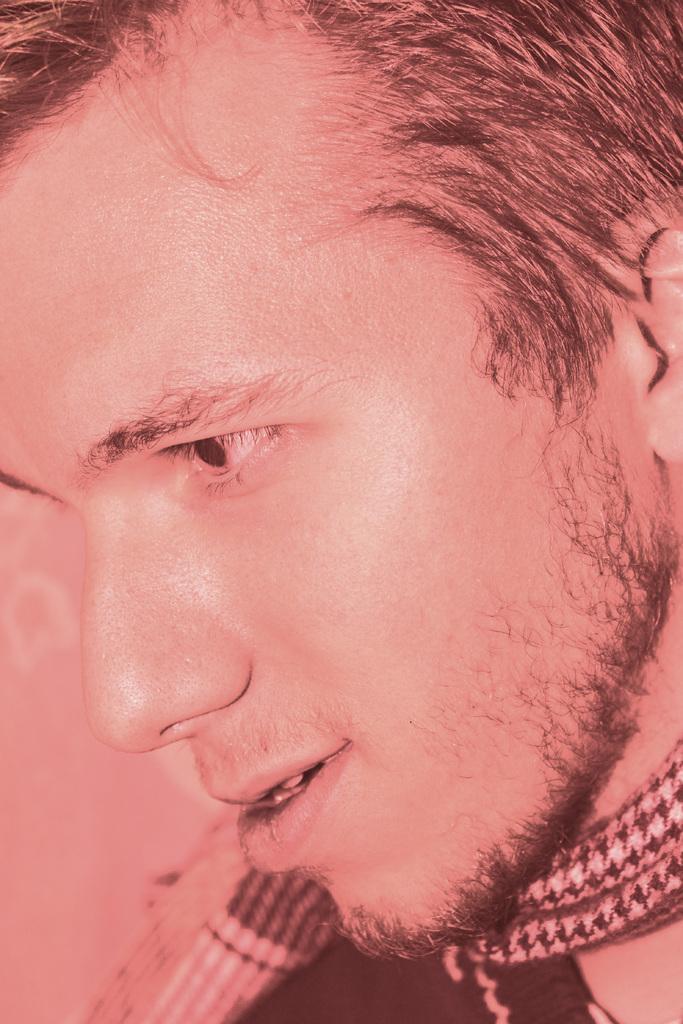Describe this image in one or two sentences. In this image I can see a man wearing black color dress and looking towards the left side. Here I can see a neck ware. 